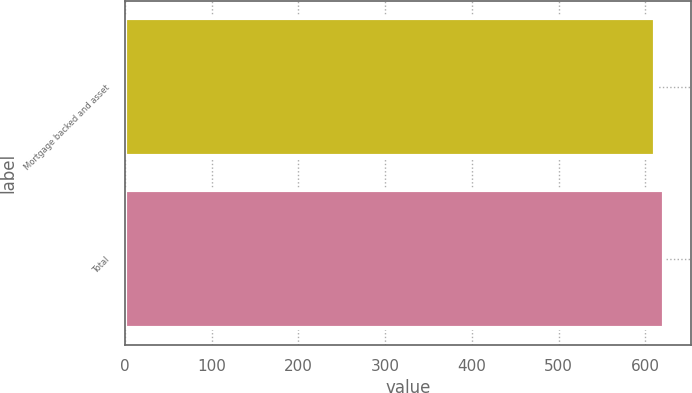<chart> <loc_0><loc_0><loc_500><loc_500><bar_chart><fcel>Mortgage backed and asset<fcel>Total<nl><fcel>611<fcel>621<nl></chart> 